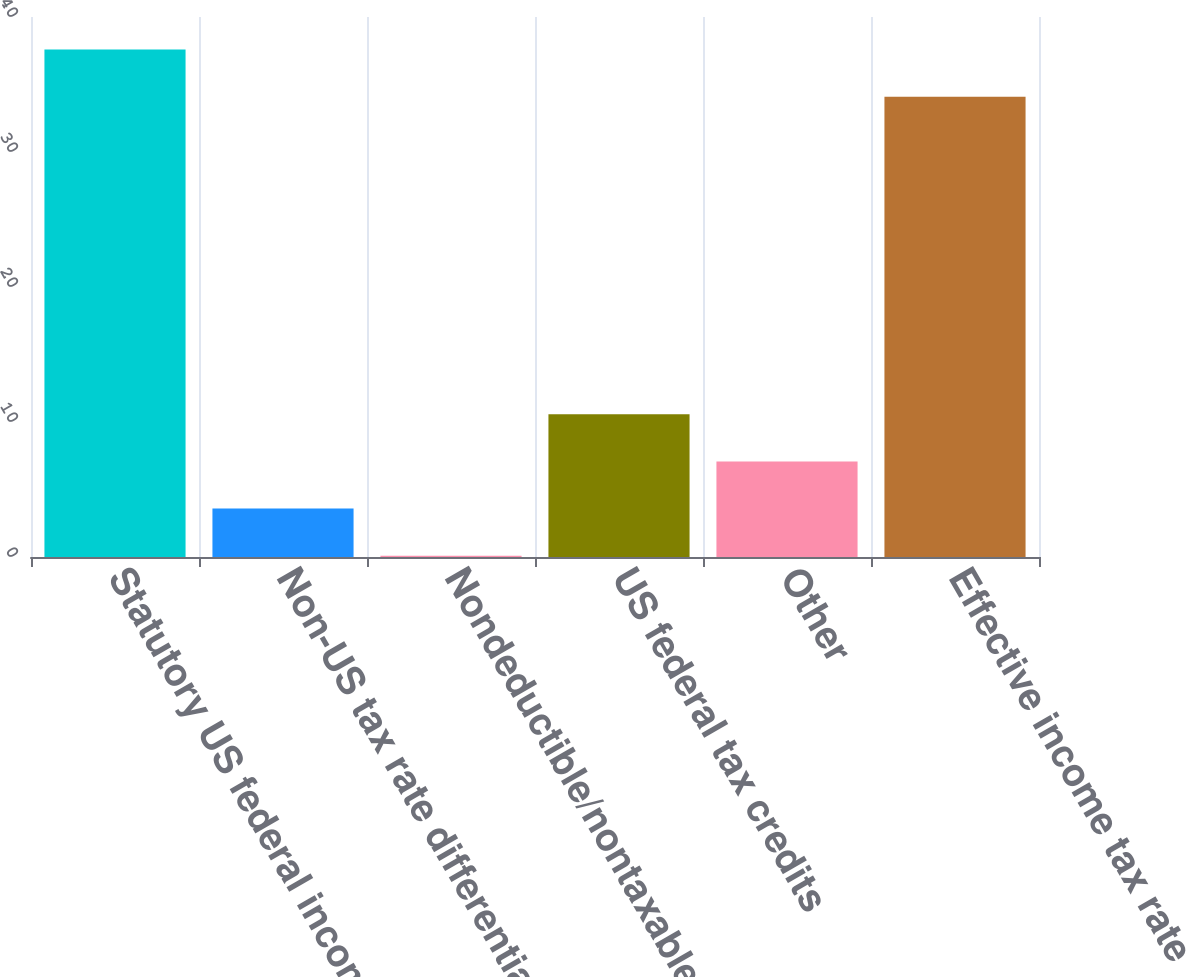Convert chart. <chart><loc_0><loc_0><loc_500><loc_500><bar_chart><fcel>Statutory US federal income<fcel>Non-US tax rate differential<fcel>Nondeductible/nontaxable items<fcel>US federal tax credits<fcel>Other<fcel>Effective income tax rate<nl><fcel>37.59<fcel>3.59<fcel>0.1<fcel>10.57<fcel>7.08<fcel>34.1<nl></chart> 